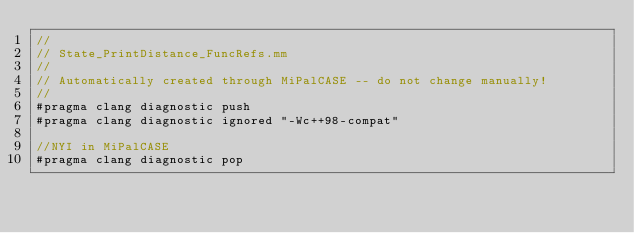Convert code to text. <code><loc_0><loc_0><loc_500><loc_500><_ObjectiveC_>//
// State_PrintDistance_FuncRefs.mm
//
// Automatically created through MiPalCASE -- do not change manually!
//
#pragma clang diagnostic push
#pragma clang diagnostic ignored "-Wc++98-compat"

//NYI in MiPalCASE
#pragma clang diagnostic pop
</code> 